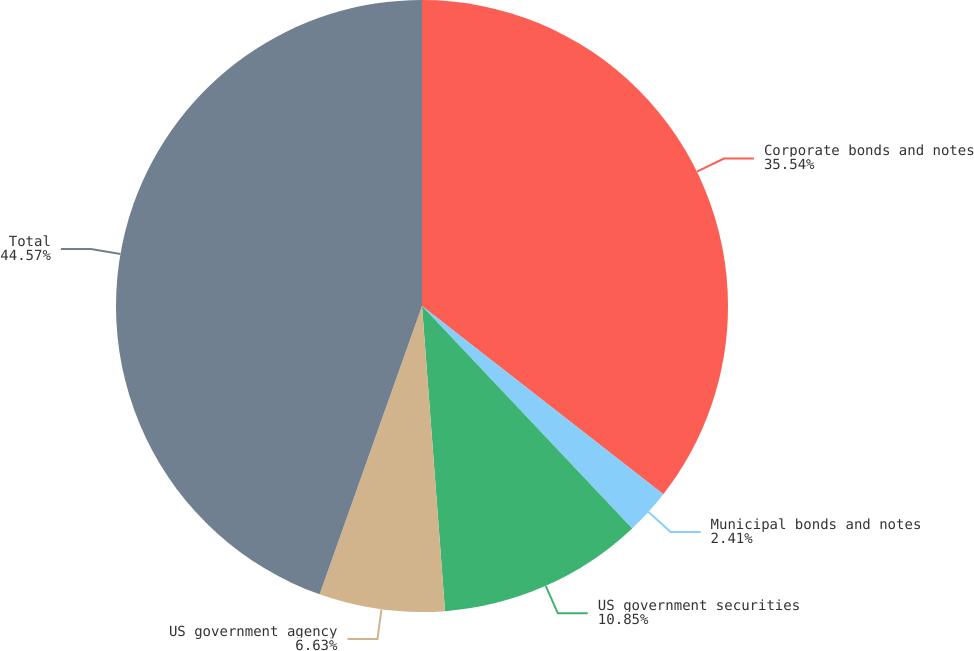Convert chart. <chart><loc_0><loc_0><loc_500><loc_500><pie_chart><fcel>Corporate bonds and notes<fcel>Municipal bonds and notes<fcel>US government securities<fcel>US government agency<fcel>Total<nl><fcel>35.54%<fcel>2.41%<fcel>10.85%<fcel>6.63%<fcel>44.57%<nl></chart> 